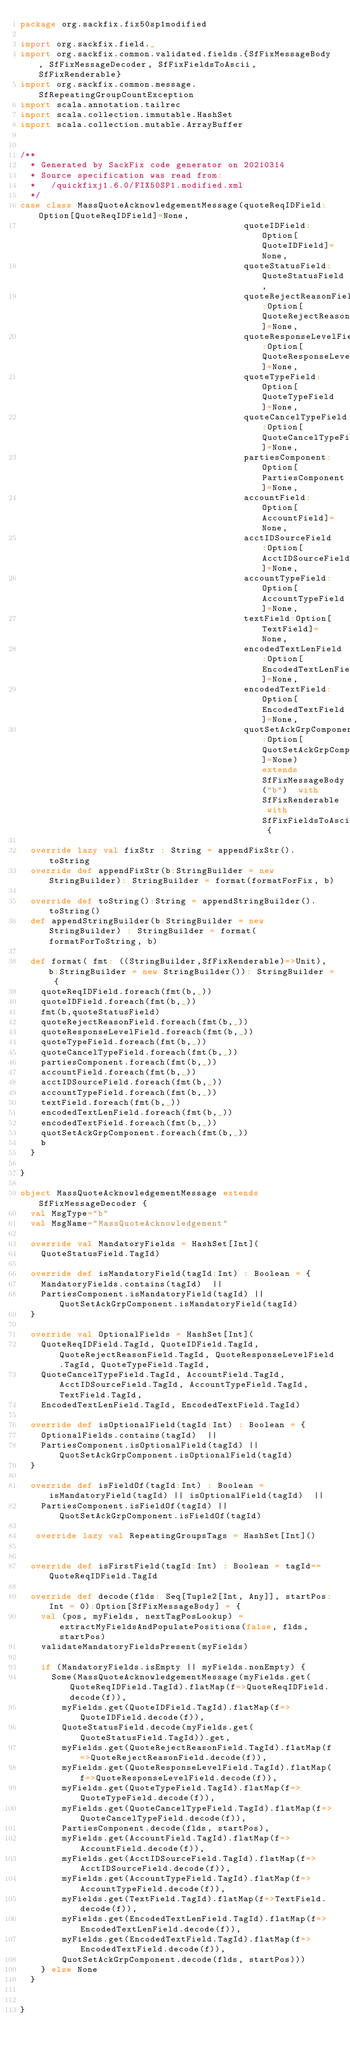Convert code to text. <code><loc_0><loc_0><loc_500><loc_500><_Scala_>package org.sackfix.fix50sp1modified

import org.sackfix.field._
import org.sackfix.common.validated.fields.{SfFixMessageBody, SfFixMessageDecoder, SfFixFieldsToAscii, SfFixRenderable}
import org.sackfix.common.message.SfRepeatingGroupCountException
import scala.annotation.tailrec
import scala.collection.immutable.HashSet
import scala.collection.mutable.ArrayBuffer


/**
  * Generated by SackFix code generator on 20210314
  * Source specification was read from:
  *   /quickfixj1.6.0/FIX50SP1.modified.xml
  */
case class MassQuoteAcknowledgementMessage(quoteReqIDField:Option[QuoteReqIDField]=None,
                                           quoteIDField:Option[QuoteIDField]=None,
                                           quoteStatusField:QuoteStatusField,
                                           quoteRejectReasonField:Option[QuoteRejectReasonField]=None,
                                           quoteResponseLevelField:Option[QuoteResponseLevelField]=None,
                                           quoteTypeField:Option[QuoteTypeField]=None,
                                           quoteCancelTypeField:Option[QuoteCancelTypeField]=None,
                                           partiesComponent:Option[PartiesComponent]=None,
                                           accountField:Option[AccountField]=None,
                                           acctIDSourceField:Option[AcctIDSourceField]=None,
                                           accountTypeField:Option[AccountTypeField]=None,
                                           textField:Option[TextField]=None,
                                           encodedTextLenField:Option[EncodedTextLenField]=None,
                                           encodedTextField:Option[EncodedTextField]=None,
                                           quotSetAckGrpComponent:Option[QuotSetAckGrpComponent]=None) extends SfFixMessageBody("b")  with SfFixRenderable with SfFixFieldsToAscii {

  override lazy val fixStr : String = appendFixStr().toString
  override def appendFixStr(b:StringBuilder = new StringBuilder): StringBuilder = format(formatForFix, b)

  override def toString():String = appendStringBuilder().toString()
  def appendStringBuilder(b:StringBuilder = new StringBuilder) : StringBuilder = format(formatForToString, b)

  def format( fmt: ((StringBuilder,SfFixRenderable)=>Unit), b:StringBuilder = new StringBuilder()): StringBuilder = {
    quoteReqIDField.foreach(fmt(b,_))
    quoteIDField.foreach(fmt(b,_))
    fmt(b,quoteStatusField)
    quoteRejectReasonField.foreach(fmt(b,_))
    quoteResponseLevelField.foreach(fmt(b,_))
    quoteTypeField.foreach(fmt(b,_))
    quoteCancelTypeField.foreach(fmt(b,_))
    partiesComponent.foreach(fmt(b,_))
    accountField.foreach(fmt(b,_))
    acctIDSourceField.foreach(fmt(b,_))
    accountTypeField.foreach(fmt(b,_))
    textField.foreach(fmt(b,_))
    encodedTextLenField.foreach(fmt(b,_))
    encodedTextField.foreach(fmt(b,_))
    quotSetAckGrpComponent.foreach(fmt(b,_))
    b
  }

}
     
object MassQuoteAcknowledgementMessage extends SfFixMessageDecoder {
  val MsgType="b"
  val MsgName="MassQuoteAcknowledgement"
             
  override val MandatoryFields = HashSet[Int](
    QuoteStatusField.TagId)

  override def isMandatoryField(tagId:Int) : Boolean = {
    MandatoryFields.contains(tagId)  || 
    PartiesComponent.isMandatoryField(tagId) || QuotSetAckGrpComponent.isMandatoryField(tagId)
  }

  override val OptionalFields = HashSet[Int](
    QuoteReqIDField.TagId, QuoteIDField.TagId, QuoteRejectReasonField.TagId, QuoteResponseLevelField.TagId, QuoteTypeField.TagId, 
    QuoteCancelTypeField.TagId, AccountField.TagId, AcctIDSourceField.TagId, AccountTypeField.TagId, TextField.TagId, 
    EncodedTextLenField.TagId, EncodedTextField.TagId)

  override def isOptionalField(tagId:Int) : Boolean = {
    OptionalFields.contains(tagId)  || 
    PartiesComponent.isOptionalField(tagId) || QuotSetAckGrpComponent.isOptionalField(tagId)
  }

  override def isFieldOf(tagId:Int) : Boolean = isMandatoryField(tagId) || isOptionalField(tagId)  || 
    PartiesComponent.isFieldOf(tagId) || QuotSetAckGrpComponent.isFieldOf(tagId)

   override lazy val RepeatingGroupsTags = HashSet[Int]()
  
      
  override def isFirstField(tagId:Int) : Boolean = tagId==QuoteReqIDField.TagId 

  override def decode(flds: Seq[Tuple2[Int, Any]], startPos:Int = 0):Option[SfFixMessageBody] = {
    val (pos, myFields, nextTagPosLookup) = extractMyFieldsAndPopulatePositions(false, flds, startPos)
    validateMandatoryFieldsPresent(myFields)

    if (MandatoryFields.isEmpty || myFields.nonEmpty) {
      Some(MassQuoteAcknowledgementMessage(myFields.get(QuoteReqIDField.TagId).flatMap(f=>QuoteReqIDField.decode(f)),
        myFields.get(QuoteIDField.TagId).flatMap(f=>QuoteIDField.decode(f)),
        QuoteStatusField.decode(myFields.get(QuoteStatusField.TagId)).get,
        myFields.get(QuoteRejectReasonField.TagId).flatMap(f=>QuoteRejectReasonField.decode(f)),
        myFields.get(QuoteResponseLevelField.TagId).flatMap(f=>QuoteResponseLevelField.decode(f)),
        myFields.get(QuoteTypeField.TagId).flatMap(f=>QuoteTypeField.decode(f)),
        myFields.get(QuoteCancelTypeField.TagId).flatMap(f=>QuoteCancelTypeField.decode(f)),
        PartiesComponent.decode(flds, startPos),
        myFields.get(AccountField.TagId).flatMap(f=>AccountField.decode(f)),
        myFields.get(AcctIDSourceField.TagId).flatMap(f=>AcctIDSourceField.decode(f)),
        myFields.get(AccountTypeField.TagId).flatMap(f=>AccountTypeField.decode(f)),
        myFields.get(TextField.TagId).flatMap(f=>TextField.decode(f)),
        myFields.get(EncodedTextLenField.TagId).flatMap(f=>EncodedTextLenField.decode(f)),
        myFields.get(EncodedTextField.TagId).flatMap(f=>EncodedTextField.decode(f)),
        QuotSetAckGrpComponent.decode(flds, startPos)))
    } else None
  }

    
}
     </code> 